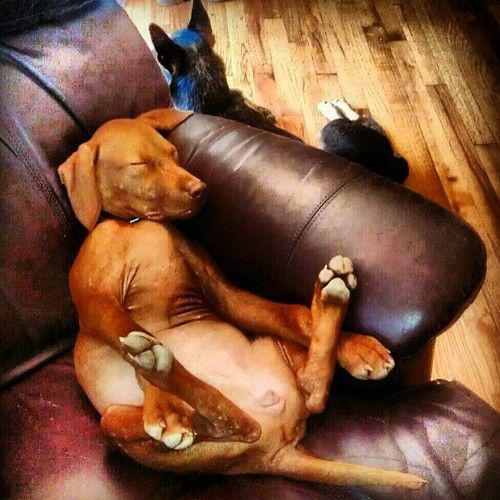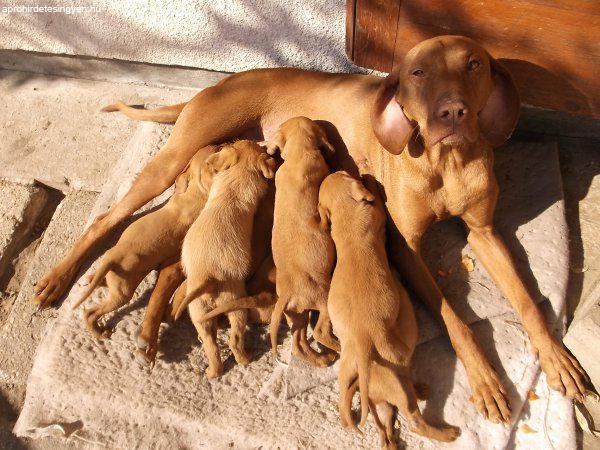The first image is the image on the left, the second image is the image on the right. Assess this claim about the two images: "Each image contains a single dog, and the right image shows a sleeping hound with its head to the right.". Correct or not? Answer yes or no. No. The first image is the image on the left, the second image is the image on the right. Evaluate the accuracy of this statement regarding the images: "The dog in the right image is sleeping.". Is it true? Answer yes or no. No. 